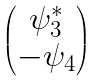<formula> <loc_0><loc_0><loc_500><loc_500>\begin{pmatrix} \psi ^ { * } _ { 3 } \\ - \psi _ { 4 } \end{pmatrix}</formula> 